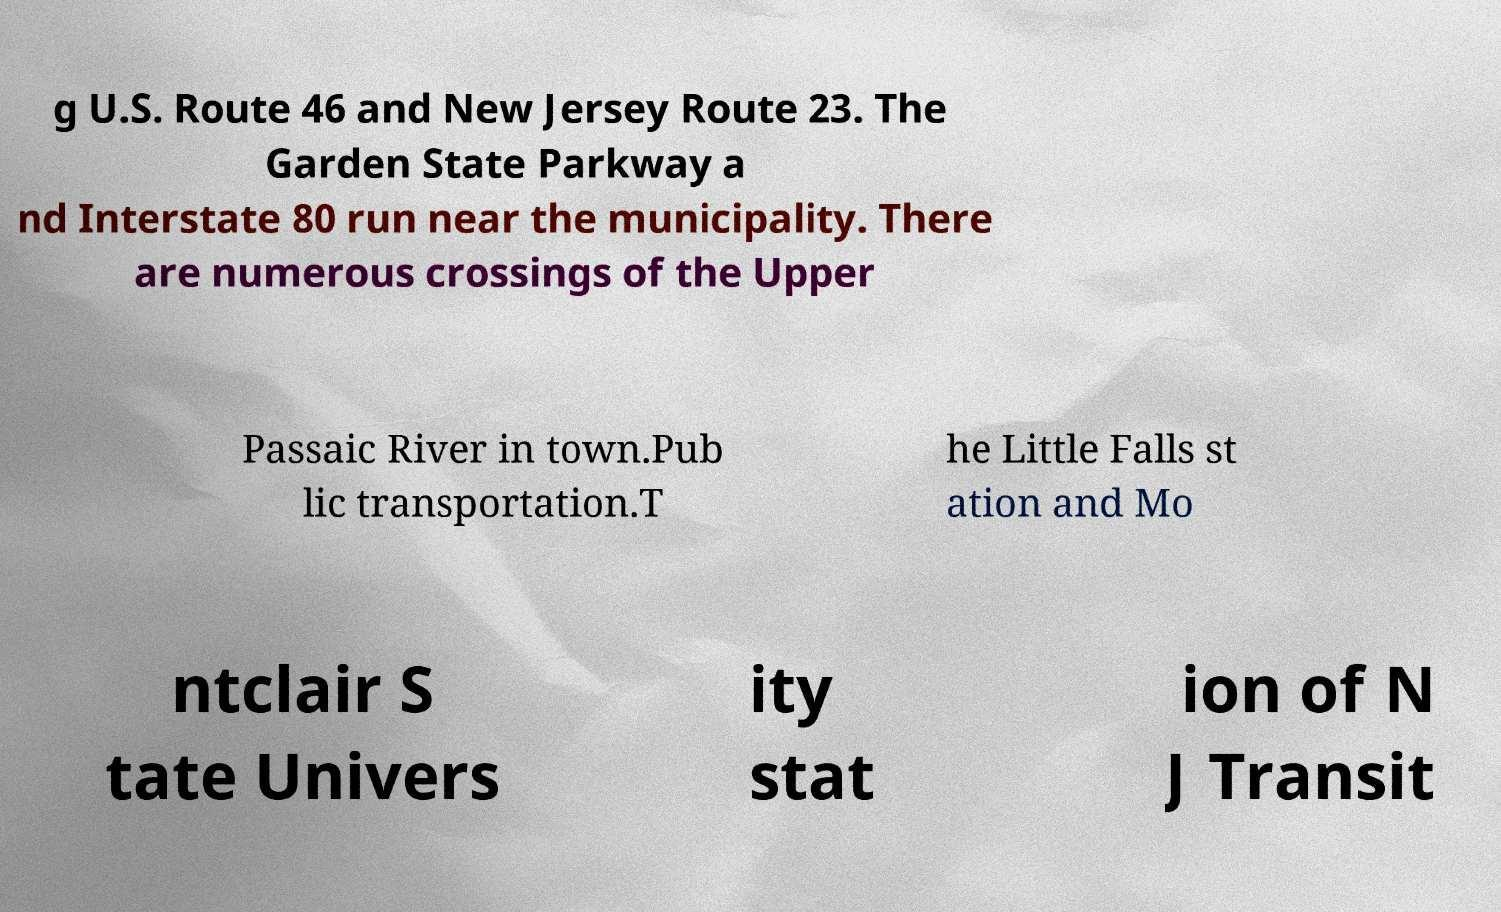Please identify and transcribe the text found in this image. g U.S. Route 46 and New Jersey Route 23. The Garden State Parkway a nd Interstate 80 run near the municipality. There are numerous crossings of the Upper Passaic River in town.Pub lic transportation.T he Little Falls st ation and Mo ntclair S tate Univers ity stat ion of N J Transit 